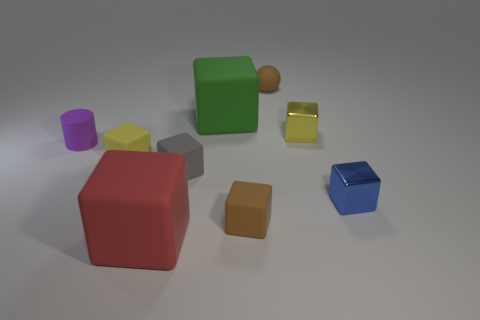There is a thing on the right side of the yellow shiny cube; is its size the same as the yellow block on the right side of the red cube?
Offer a very short reply. Yes. How many other things are the same size as the brown rubber ball?
Make the answer very short. 6. How many big green cubes are on the right side of the yellow cube to the right of the yellow rubber object?
Provide a short and direct response. 0. Are there fewer purple rubber cylinders in front of the gray matte block than gray cubes?
Your answer should be compact. Yes. There is a small blue metallic object that is right of the big cube in front of the large block behind the blue shiny block; what is its shape?
Provide a succinct answer. Cube. Do the small blue metal thing and the small yellow rubber object have the same shape?
Offer a terse response. Yes. How many other things are the same shape as the small gray rubber thing?
Provide a short and direct response. 6. There is a rubber ball that is the same size as the rubber cylinder; what color is it?
Provide a short and direct response. Brown. Is the number of blue cubes that are in front of the blue block the same as the number of tiny blue cylinders?
Your response must be concise. Yes. There is a tiny object that is both on the left side of the yellow shiny thing and behind the tiny purple rubber object; what is its shape?
Your answer should be very brief. Sphere. 